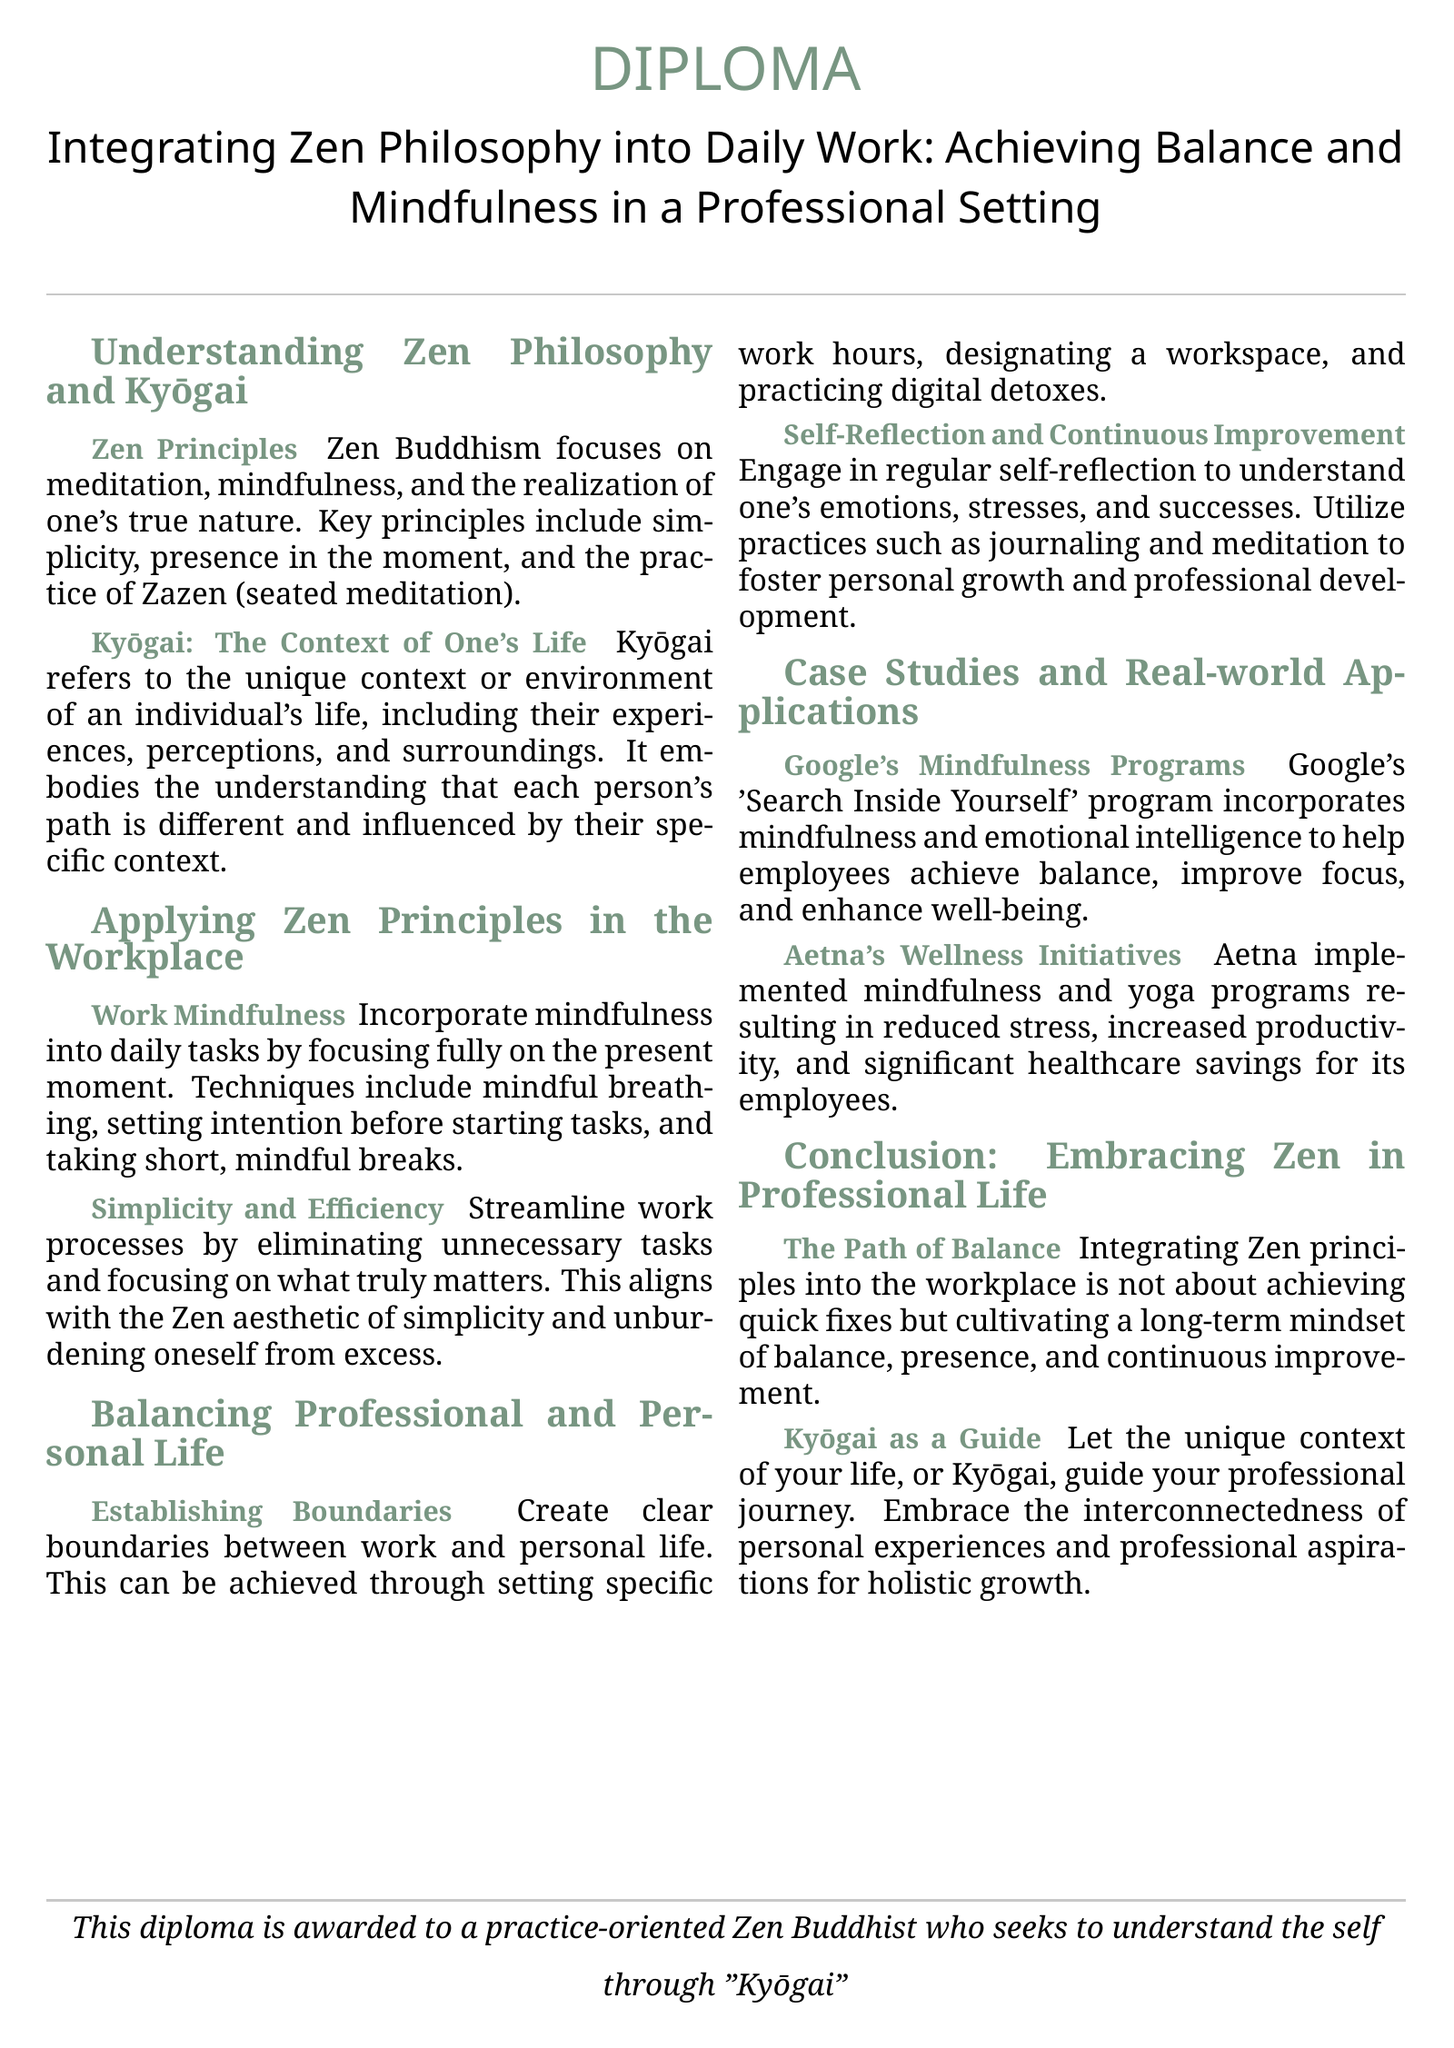what is the title of the diploma? The title summarizes the main focus of the diploma which is "Integrating Zen Philosophy into Daily Work: Achieving Balance and Mindfulness in a Professional Setting."
Answer: Integrating Zen Philosophy into Daily Work: Achieving Balance and Mindfulness in a Professional Setting what is Kyōgai? Kyōgai refers to the unique context or environment of an individual's life, including their experiences, perceptions, and surroundings.
Answer: unique context what are two techniques mentioned for work mindfulness? The document lists mindful breathing and taking short, mindful breaks as techniques for incorporating mindfulness into daily tasks.
Answer: mindful breathing, mindful breaks which company implemented mindfulness and yoga programs? The document mentions Aetna as a company that implemented mindfulness and yoga programs leading to various positive outcomes for its employees.
Answer: Aetna what is emphasized as a path of balance in professional life? The conclusion emphasizes that integrating Zen principles into the workplace is about cultivating a long-term mindset of balance and presence.
Answer: cultivating a long-term mindset what does the diploma indicate about the recipient? The diploma provides a specific descriptor of the recipient's orientation, which is that they are a practice-oriented Zen Buddhist.
Answer: practice-oriented Zen Buddhist what color is used for the section titles? The section titles use a color defined in the document, which is zengreen.
Answer: zengreen how many sections are there in the diploma? The document contains five main sections, covering different aspects of integrating Zen philosophy into daily work.
Answer: five 